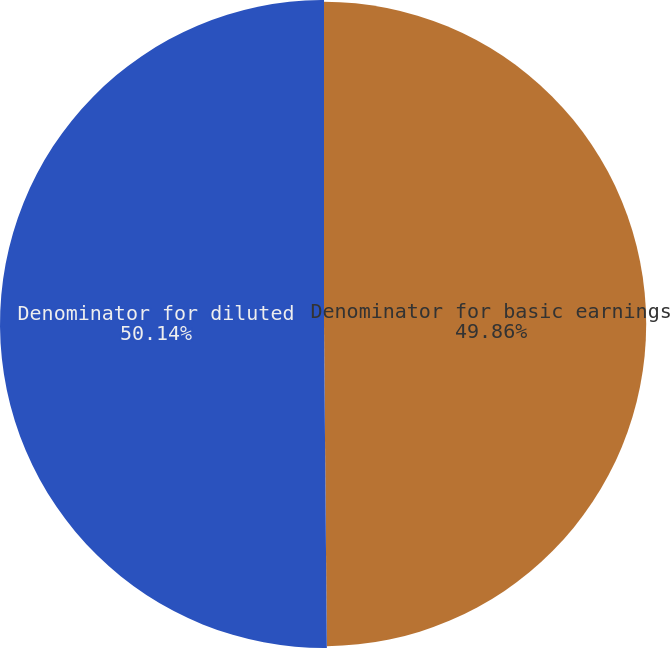Convert chart to OTSL. <chart><loc_0><loc_0><loc_500><loc_500><pie_chart><fcel>Denominator for basic earnings<fcel>Denominator for diluted<nl><fcel>49.86%<fcel>50.14%<nl></chart> 